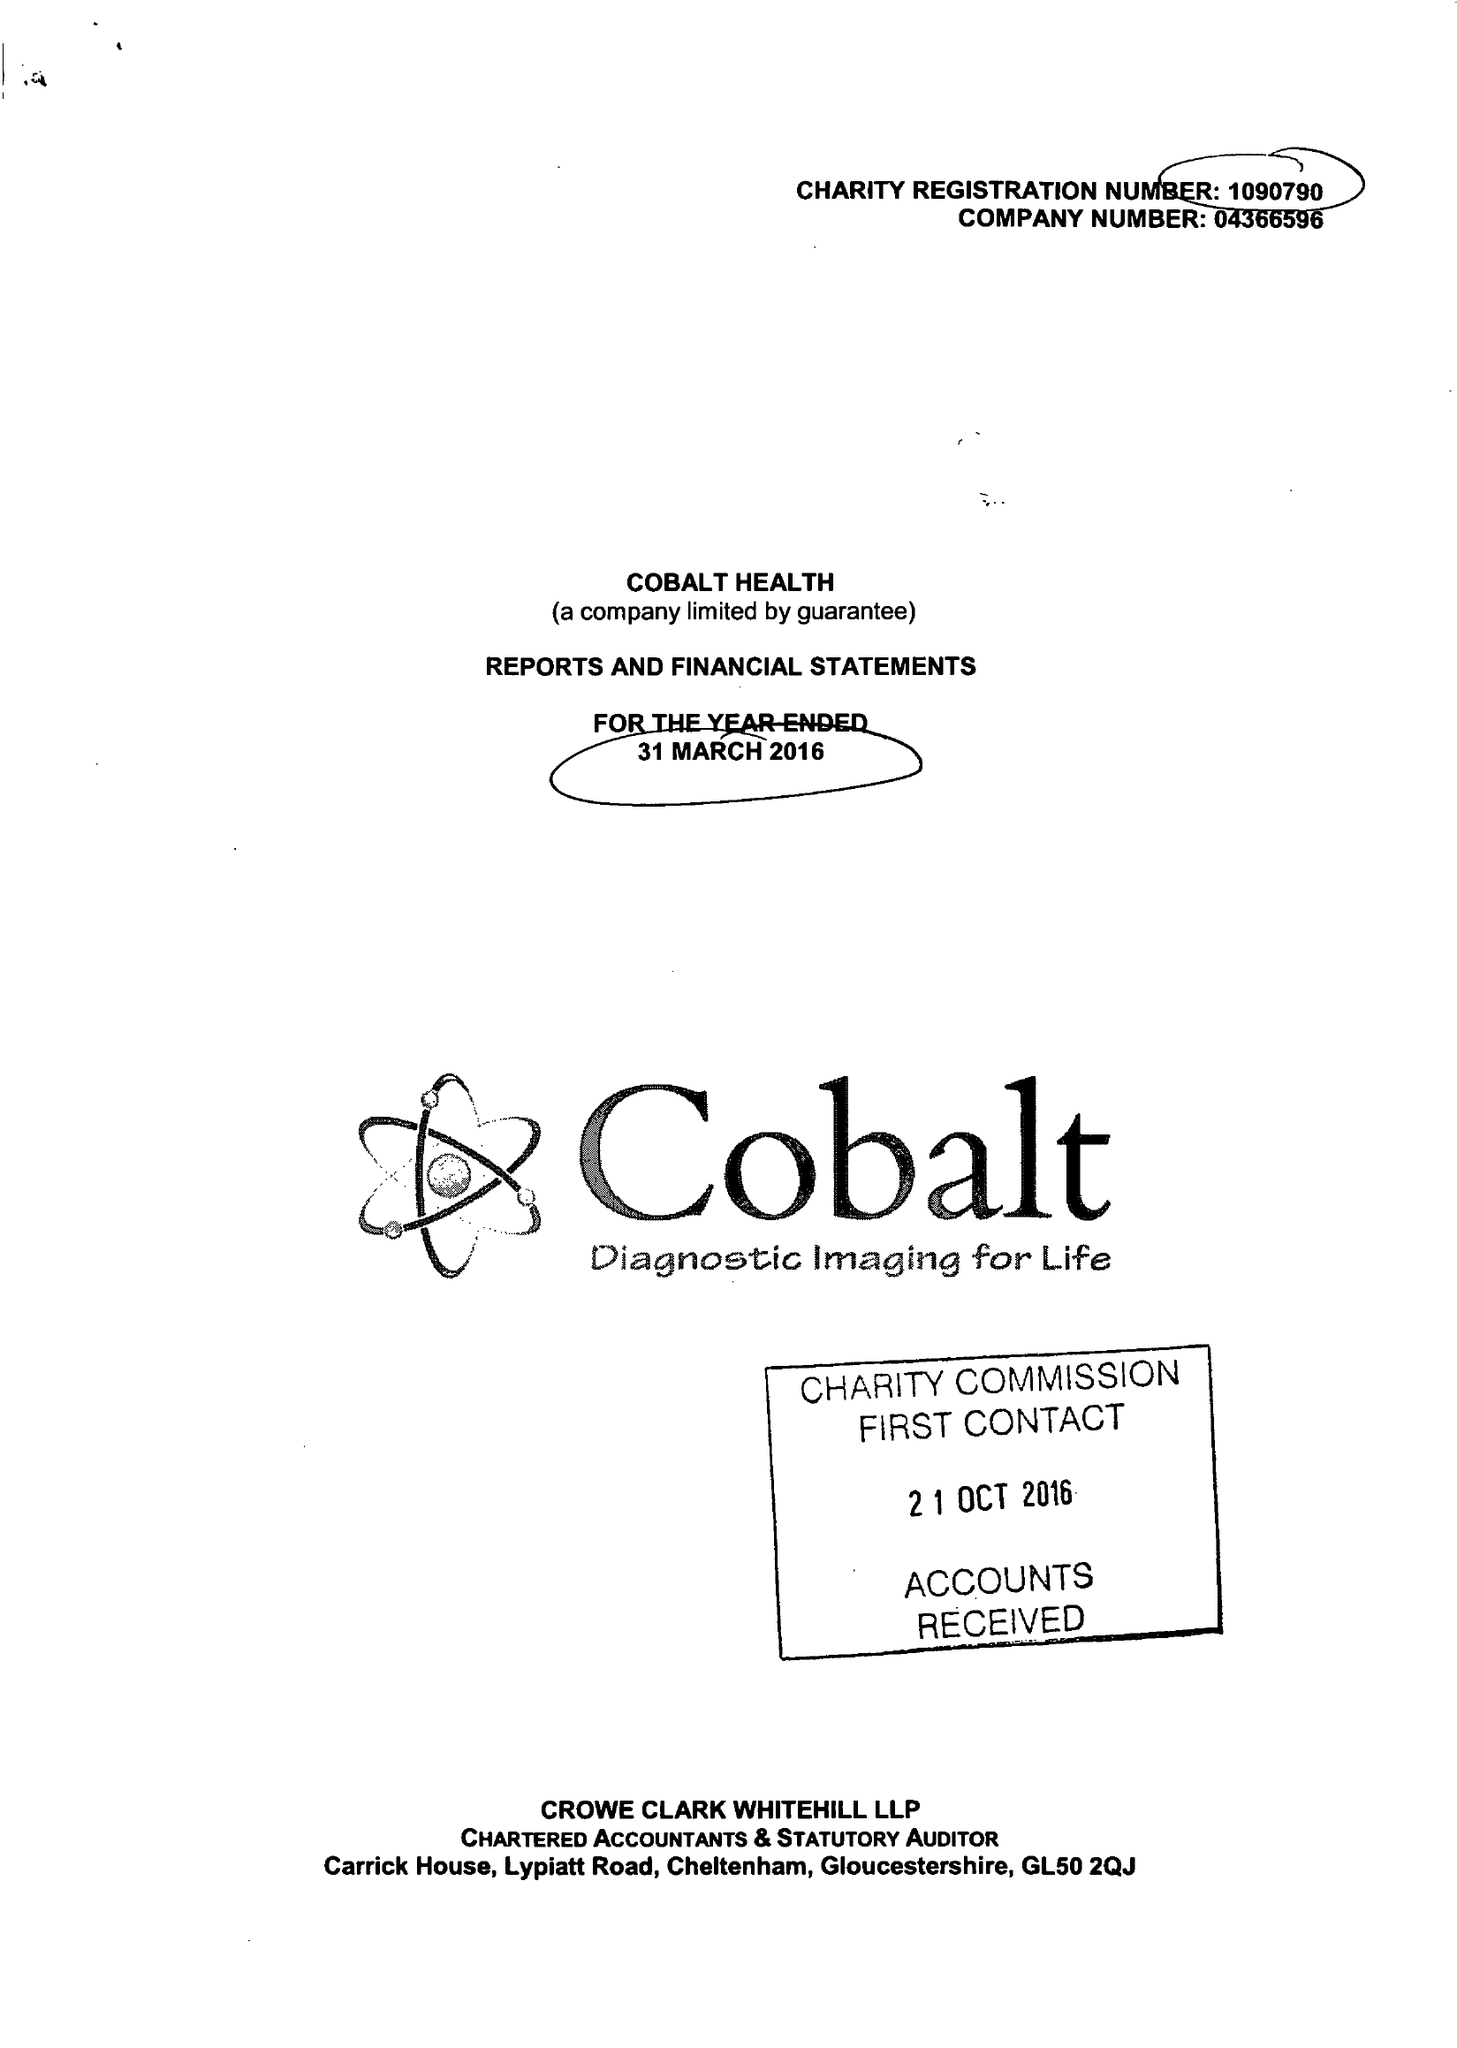What is the value for the address__postcode?
Answer the question using a single word or phrase. GL53 7AS 